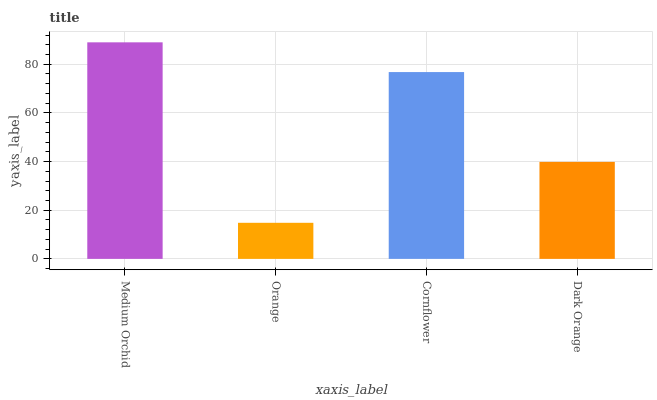Is Orange the minimum?
Answer yes or no. Yes. Is Medium Orchid the maximum?
Answer yes or no. Yes. Is Cornflower the minimum?
Answer yes or no. No. Is Cornflower the maximum?
Answer yes or no. No. Is Cornflower greater than Orange?
Answer yes or no. Yes. Is Orange less than Cornflower?
Answer yes or no. Yes. Is Orange greater than Cornflower?
Answer yes or no. No. Is Cornflower less than Orange?
Answer yes or no. No. Is Cornflower the high median?
Answer yes or no. Yes. Is Dark Orange the low median?
Answer yes or no. Yes. Is Orange the high median?
Answer yes or no. No. Is Cornflower the low median?
Answer yes or no. No. 